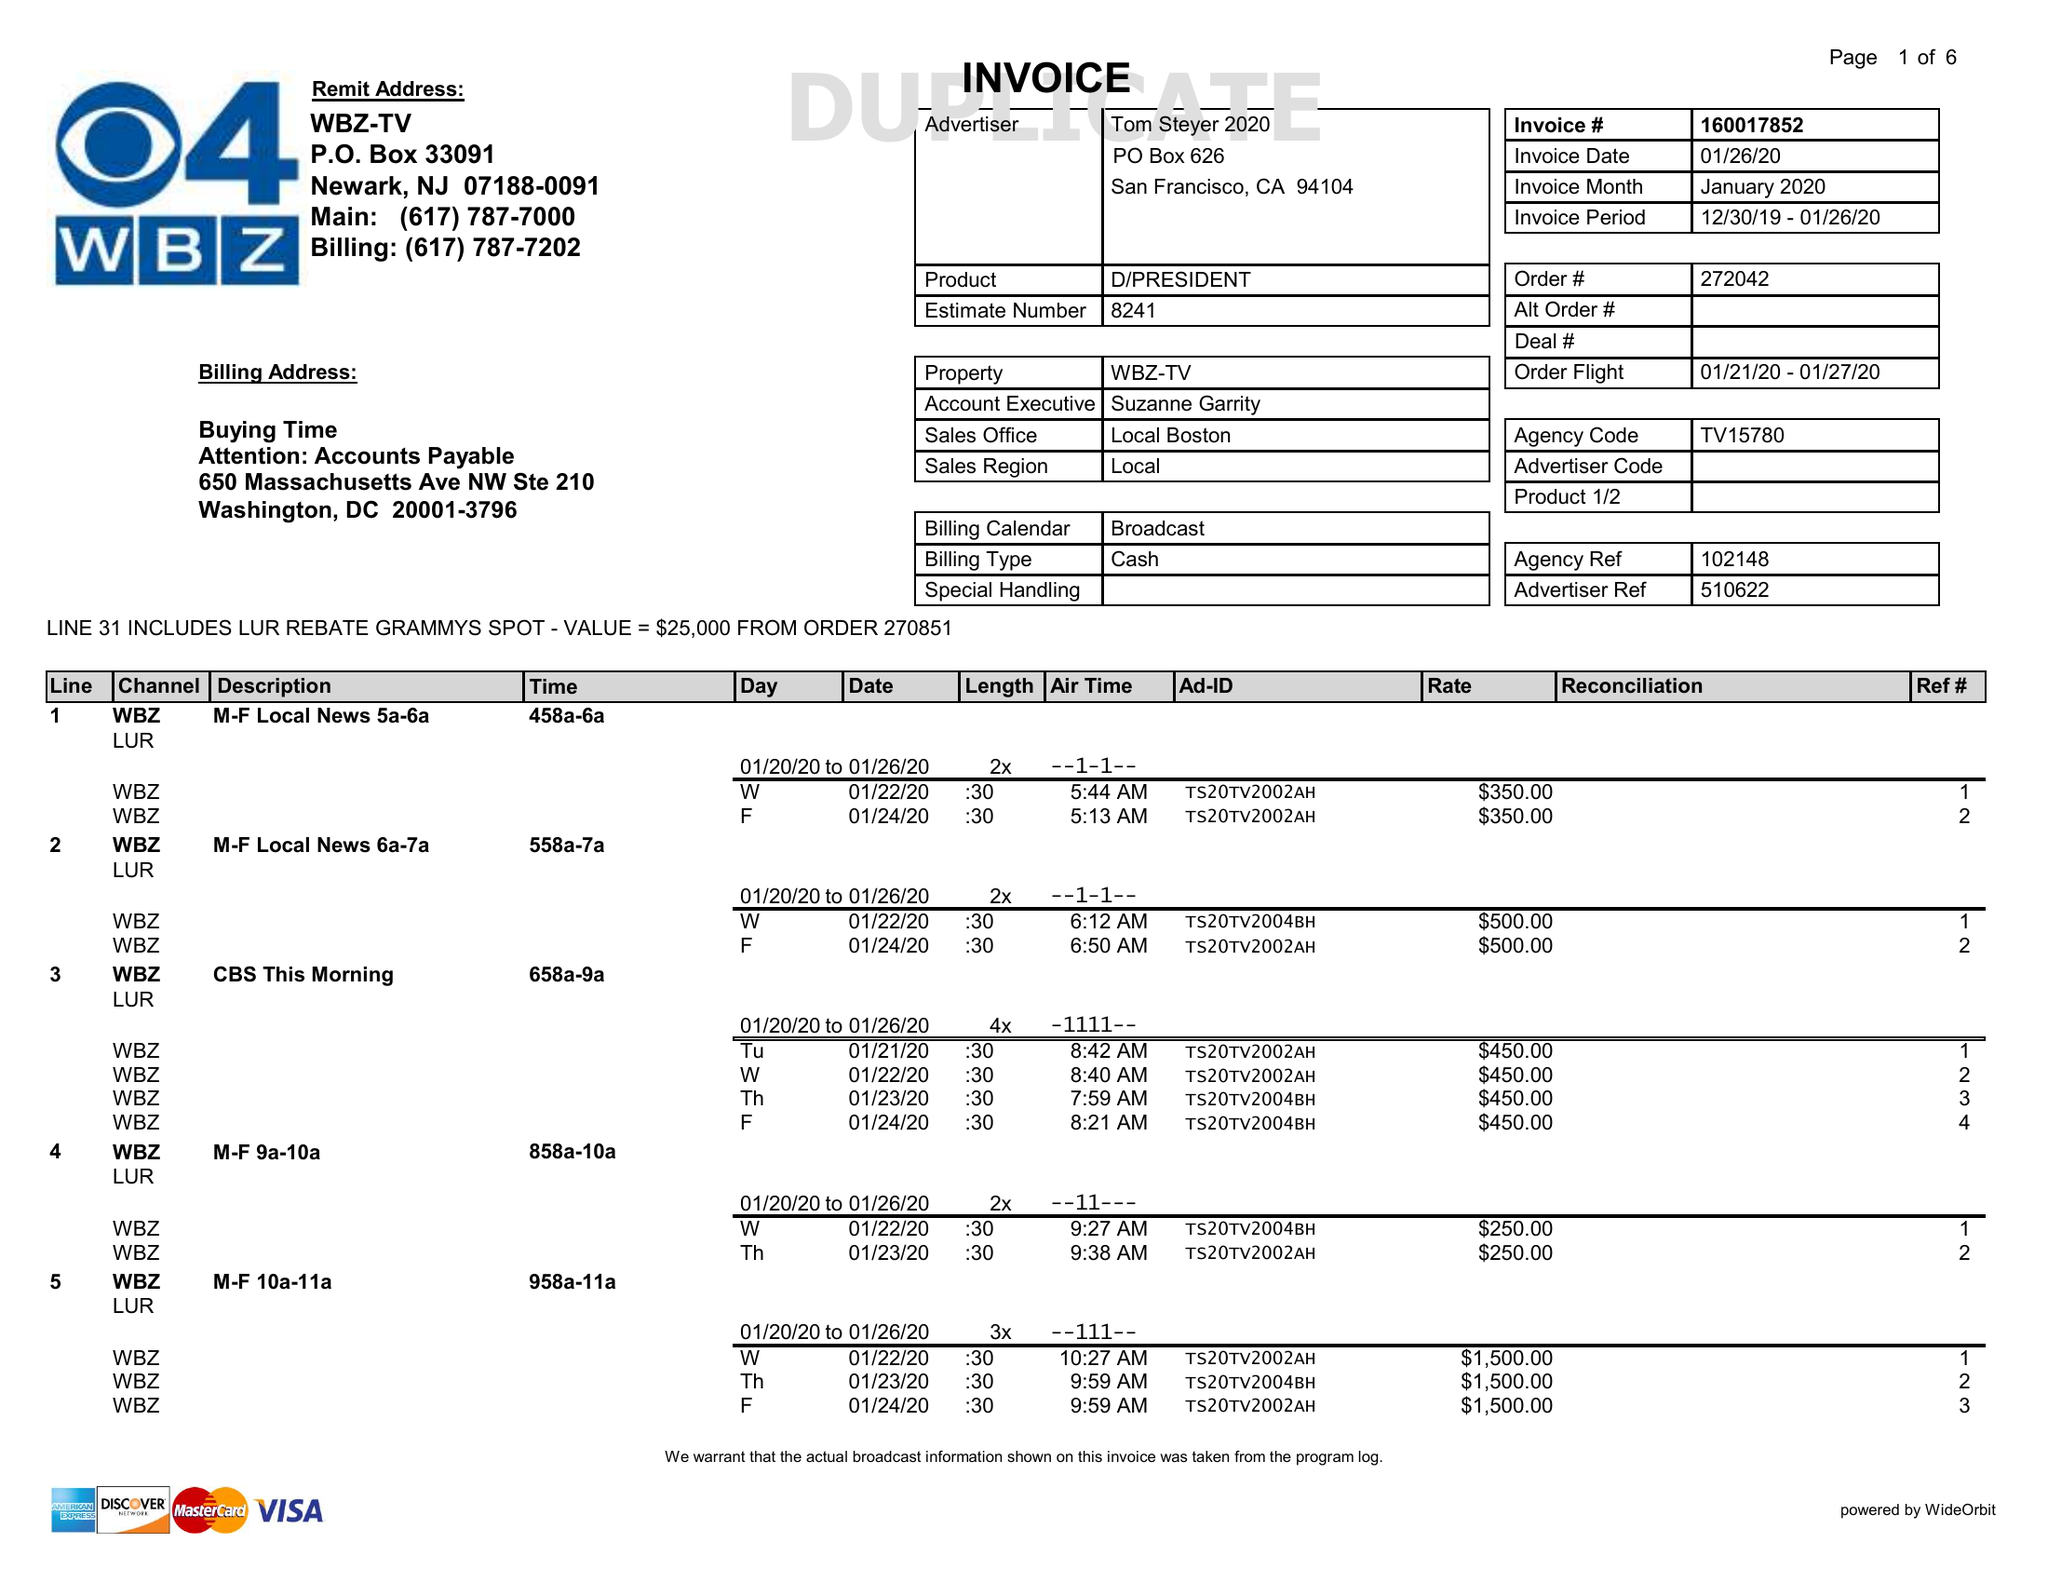What is the value for the advertiser?
Answer the question using a single word or phrase. TOM STEYER 2020 